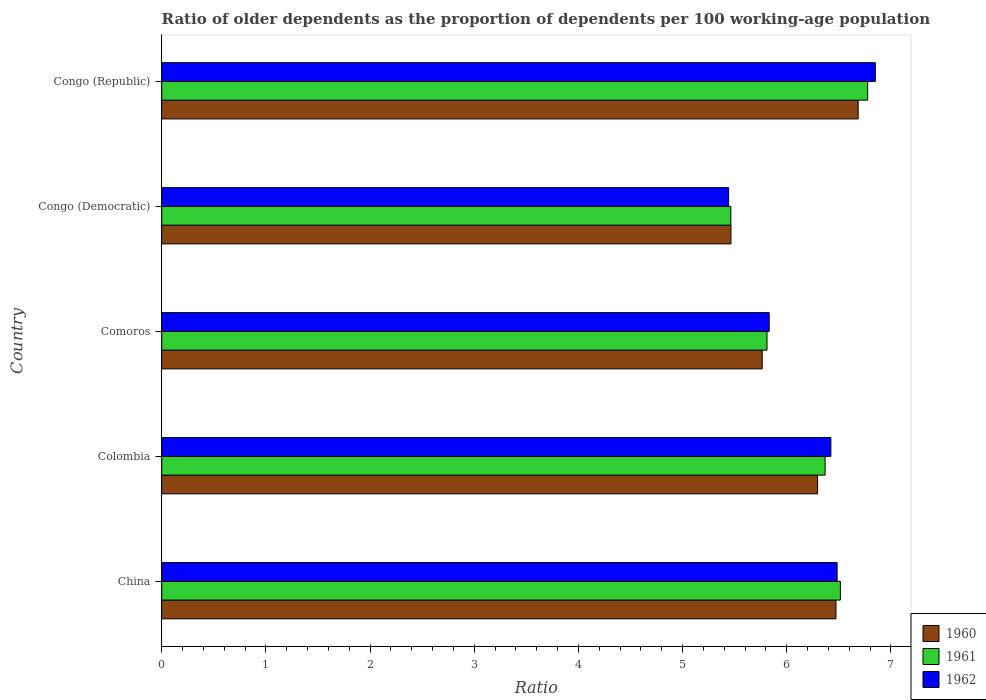Are the number of bars on each tick of the Y-axis equal?
Offer a terse response. Yes. How many bars are there on the 4th tick from the top?
Offer a terse response. 3. What is the label of the 3rd group of bars from the top?
Make the answer very short. Comoros. What is the age dependency ratio(old) in 1961 in Congo (Republic)?
Offer a terse response. 6.78. Across all countries, what is the maximum age dependency ratio(old) in 1962?
Your response must be concise. 6.85. Across all countries, what is the minimum age dependency ratio(old) in 1961?
Offer a very short reply. 5.46. In which country was the age dependency ratio(old) in 1962 maximum?
Give a very brief answer. Congo (Republic). In which country was the age dependency ratio(old) in 1962 minimum?
Ensure brevity in your answer.  Congo (Democratic). What is the total age dependency ratio(old) in 1962 in the graph?
Give a very brief answer. 31.03. What is the difference between the age dependency ratio(old) in 1961 in Colombia and that in Comoros?
Your answer should be compact. 0.56. What is the difference between the age dependency ratio(old) in 1962 in Comoros and the age dependency ratio(old) in 1960 in Congo (Democratic)?
Your response must be concise. 0.37. What is the average age dependency ratio(old) in 1962 per country?
Your answer should be compact. 6.21. What is the difference between the age dependency ratio(old) in 1961 and age dependency ratio(old) in 1962 in Comoros?
Make the answer very short. -0.02. What is the ratio of the age dependency ratio(old) in 1961 in Congo (Democratic) to that in Congo (Republic)?
Your answer should be very brief. 0.81. Is the age dependency ratio(old) in 1960 in China less than that in Colombia?
Give a very brief answer. No. What is the difference between the highest and the second highest age dependency ratio(old) in 1962?
Provide a short and direct response. 0.37. What is the difference between the highest and the lowest age dependency ratio(old) in 1962?
Your answer should be compact. 1.41. In how many countries, is the age dependency ratio(old) in 1960 greater than the average age dependency ratio(old) in 1960 taken over all countries?
Your answer should be compact. 3. Is the sum of the age dependency ratio(old) in 1962 in Colombia and Congo (Republic) greater than the maximum age dependency ratio(old) in 1960 across all countries?
Your answer should be very brief. Yes. Is it the case that in every country, the sum of the age dependency ratio(old) in 1961 and age dependency ratio(old) in 1960 is greater than the age dependency ratio(old) in 1962?
Give a very brief answer. Yes. How many bars are there?
Give a very brief answer. 15. Are all the bars in the graph horizontal?
Offer a terse response. Yes. How many countries are there in the graph?
Offer a terse response. 5. Does the graph contain any zero values?
Provide a short and direct response. No. Does the graph contain grids?
Your answer should be very brief. No. What is the title of the graph?
Provide a succinct answer. Ratio of older dependents as the proportion of dependents per 100 working-age population. What is the label or title of the X-axis?
Offer a very short reply. Ratio. What is the label or title of the Y-axis?
Your answer should be compact. Country. What is the Ratio of 1960 in China?
Provide a short and direct response. 6.47. What is the Ratio in 1961 in China?
Your answer should be compact. 6.51. What is the Ratio in 1962 in China?
Offer a terse response. 6.48. What is the Ratio in 1960 in Colombia?
Ensure brevity in your answer.  6.3. What is the Ratio in 1961 in Colombia?
Your answer should be very brief. 6.37. What is the Ratio of 1962 in Colombia?
Your answer should be compact. 6.42. What is the Ratio in 1960 in Comoros?
Your response must be concise. 5.76. What is the Ratio of 1961 in Comoros?
Ensure brevity in your answer.  5.81. What is the Ratio in 1962 in Comoros?
Keep it short and to the point. 5.83. What is the Ratio of 1960 in Congo (Democratic)?
Provide a short and direct response. 5.46. What is the Ratio of 1961 in Congo (Democratic)?
Make the answer very short. 5.46. What is the Ratio in 1962 in Congo (Democratic)?
Give a very brief answer. 5.44. What is the Ratio of 1960 in Congo (Republic)?
Give a very brief answer. 6.69. What is the Ratio in 1961 in Congo (Republic)?
Provide a short and direct response. 6.78. What is the Ratio in 1962 in Congo (Republic)?
Your answer should be compact. 6.85. Across all countries, what is the maximum Ratio in 1960?
Make the answer very short. 6.69. Across all countries, what is the maximum Ratio of 1961?
Provide a short and direct response. 6.78. Across all countries, what is the maximum Ratio of 1962?
Provide a succinct answer. 6.85. Across all countries, what is the minimum Ratio of 1960?
Provide a short and direct response. 5.46. Across all countries, what is the minimum Ratio in 1961?
Ensure brevity in your answer.  5.46. Across all countries, what is the minimum Ratio in 1962?
Ensure brevity in your answer.  5.44. What is the total Ratio in 1960 in the graph?
Give a very brief answer. 30.68. What is the total Ratio of 1961 in the graph?
Make the answer very short. 30.93. What is the total Ratio in 1962 in the graph?
Provide a short and direct response. 31.03. What is the difference between the Ratio of 1960 in China and that in Colombia?
Provide a short and direct response. 0.18. What is the difference between the Ratio in 1961 in China and that in Colombia?
Your response must be concise. 0.15. What is the difference between the Ratio of 1960 in China and that in Comoros?
Provide a succinct answer. 0.71. What is the difference between the Ratio of 1961 in China and that in Comoros?
Offer a terse response. 0.7. What is the difference between the Ratio in 1962 in China and that in Comoros?
Provide a succinct answer. 0.65. What is the difference between the Ratio of 1960 in China and that in Congo (Democratic)?
Your answer should be compact. 1.01. What is the difference between the Ratio of 1961 in China and that in Congo (Democratic)?
Offer a terse response. 1.05. What is the difference between the Ratio in 1962 in China and that in Congo (Democratic)?
Your answer should be very brief. 1.04. What is the difference between the Ratio in 1960 in China and that in Congo (Republic)?
Keep it short and to the point. -0.21. What is the difference between the Ratio in 1961 in China and that in Congo (Republic)?
Ensure brevity in your answer.  -0.26. What is the difference between the Ratio of 1962 in China and that in Congo (Republic)?
Ensure brevity in your answer.  -0.37. What is the difference between the Ratio in 1960 in Colombia and that in Comoros?
Your response must be concise. 0.53. What is the difference between the Ratio of 1961 in Colombia and that in Comoros?
Your answer should be very brief. 0.56. What is the difference between the Ratio in 1962 in Colombia and that in Comoros?
Your response must be concise. 0.59. What is the difference between the Ratio in 1960 in Colombia and that in Congo (Democratic)?
Offer a very short reply. 0.83. What is the difference between the Ratio of 1961 in Colombia and that in Congo (Democratic)?
Your answer should be very brief. 0.91. What is the difference between the Ratio in 1962 in Colombia and that in Congo (Democratic)?
Offer a terse response. 0.98. What is the difference between the Ratio of 1960 in Colombia and that in Congo (Republic)?
Offer a very short reply. -0.39. What is the difference between the Ratio of 1961 in Colombia and that in Congo (Republic)?
Offer a terse response. -0.41. What is the difference between the Ratio in 1962 in Colombia and that in Congo (Republic)?
Give a very brief answer. -0.43. What is the difference between the Ratio in 1960 in Comoros and that in Congo (Democratic)?
Your answer should be very brief. 0.3. What is the difference between the Ratio in 1961 in Comoros and that in Congo (Democratic)?
Provide a short and direct response. 0.35. What is the difference between the Ratio of 1962 in Comoros and that in Congo (Democratic)?
Give a very brief answer. 0.39. What is the difference between the Ratio in 1960 in Comoros and that in Congo (Republic)?
Your answer should be compact. -0.92. What is the difference between the Ratio of 1961 in Comoros and that in Congo (Republic)?
Offer a very short reply. -0.97. What is the difference between the Ratio of 1962 in Comoros and that in Congo (Republic)?
Your answer should be very brief. -1.02. What is the difference between the Ratio of 1960 in Congo (Democratic) and that in Congo (Republic)?
Give a very brief answer. -1.22. What is the difference between the Ratio of 1961 in Congo (Democratic) and that in Congo (Republic)?
Provide a succinct answer. -1.31. What is the difference between the Ratio of 1962 in Congo (Democratic) and that in Congo (Republic)?
Offer a terse response. -1.41. What is the difference between the Ratio of 1960 in China and the Ratio of 1961 in Colombia?
Provide a succinct answer. 0.1. What is the difference between the Ratio of 1960 in China and the Ratio of 1962 in Colombia?
Ensure brevity in your answer.  0.05. What is the difference between the Ratio in 1961 in China and the Ratio in 1962 in Colombia?
Make the answer very short. 0.09. What is the difference between the Ratio of 1960 in China and the Ratio of 1961 in Comoros?
Offer a very short reply. 0.66. What is the difference between the Ratio in 1960 in China and the Ratio in 1962 in Comoros?
Your response must be concise. 0.64. What is the difference between the Ratio of 1961 in China and the Ratio of 1962 in Comoros?
Your answer should be very brief. 0.68. What is the difference between the Ratio in 1960 in China and the Ratio in 1961 in Congo (Democratic)?
Give a very brief answer. 1.01. What is the difference between the Ratio of 1960 in China and the Ratio of 1962 in Congo (Democratic)?
Provide a short and direct response. 1.03. What is the difference between the Ratio in 1961 in China and the Ratio in 1962 in Congo (Democratic)?
Your answer should be very brief. 1.07. What is the difference between the Ratio of 1960 in China and the Ratio of 1961 in Congo (Republic)?
Offer a very short reply. -0.3. What is the difference between the Ratio in 1960 in China and the Ratio in 1962 in Congo (Republic)?
Your response must be concise. -0.38. What is the difference between the Ratio of 1961 in China and the Ratio of 1962 in Congo (Republic)?
Provide a succinct answer. -0.34. What is the difference between the Ratio of 1960 in Colombia and the Ratio of 1961 in Comoros?
Your answer should be compact. 0.49. What is the difference between the Ratio of 1960 in Colombia and the Ratio of 1962 in Comoros?
Offer a terse response. 0.46. What is the difference between the Ratio in 1961 in Colombia and the Ratio in 1962 in Comoros?
Provide a short and direct response. 0.54. What is the difference between the Ratio in 1960 in Colombia and the Ratio in 1961 in Congo (Democratic)?
Ensure brevity in your answer.  0.83. What is the difference between the Ratio in 1960 in Colombia and the Ratio in 1962 in Congo (Democratic)?
Your response must be concise. 0.85. What is the difference between the Ratio of 1961 in Colombia and the Ratio of 1962 in Congo (Democratic)?
Make the answer very short. 0.93. What is the difference between the Ratio in 1960 in Colombia and the Ratio in 1961 in Congo (Republic)?
Offer a very short reply. -0.48. What is the difference between the Ratio in 1960 in Colombia and the Ratio in 1962 in Congo (Republic)?
Offer a very short reply. -0.55. What is the difference between the Ratio of 1961 in Colombia and the Ratio of 1962 in Congo (Republic)?
Keep it short and to the point. -0.48. What is the difference between the Ratio of 1960 in Comoros and the Ratio of 1961 in Congo (Democratic)?
Give a very brief answer. 0.3. What is the difference between the Ratio in 1960 in Comoros and the Ratio in 1962 in Congo (Democratic)?
Keep it short and to the point. 0.32. What is the difference between the Ratio in 1961 in Comoros and the Ratio in 1962 in Congo (Democratic)?
Keep it short and to the point. 0.37. What is the difference between the Ratio in 1960 in Comoros and the Ratio in 1961 in Congo (Republic)?
Your response must be concise. -1.01. What is the difference between the Ratio in 1960 in Comoros and the Ratio in 1962 in Congo (Republic)?
Give a very brief answer. -1.09. What is the difference between the Ratio of 1961 in Comoros and the Ratio of 1962 in Congo (Republic)?
Provide a succinct answer. -1.04. What is the difference between the Ratio in 1960 in Congo (Democratic) and the Ratio in 1961 in Congo (Republic)?
Keep it short and to the point. -1.31. What is the difference between the Ratio in 1960 in Congo (Democratic) and the Ratio in 1962 in Congo (Republic)?
Provide a short and direct response. -1.39. What is the difference between the Ratio of 1961 in Congo (Democratic) and the Ratio of 1962 in Congo (Republic)?
Provide a succinct answer. -1.39. What is the average Ratio in 1960 per country?
Your answer should be compact. 6.14. What is the average Ratio of 1961 per country?
Provide a succinct answer. 6.19. What is the average Ratio in 1962 per country?
Ensure brevity in your answer.  6.21. What is the difference between the Ratio in 1960 and Ratio in 1961 in China?
Offer a terse response. -0.04. What is the difference between the Ratio of 1960 and Ratio of 1962 in China?
Offer a very short reply. -0.01. What is the difference between the Ratio of 1961 and Ratio of 1962 in China?
Offer a terse response. 0.03. What is the difference between the Ratio in 1960 and Ratio in 1961 in Colombia?
Your response must be concise. -0.07. What is the difference between the Ratio in 1960 and Ratio in 1962 in Colombia?
Offer a very short reply. -0.13. What is the difference between the Ratio of 1961 and Ratio of 1962 in Colombia?
Provide a short and direct response. -0.06. What is the difference between the Ratio of 1960 and Ratio of 1961 in Comoros?
Give a very brief answer. -0.05. What is the difference between the Ratio of 1960 and Ratio of 1962 in Comoros?
Your answer should be compact. -0.07. What is the difference between the Ratio in 1961 and Ratio in 1962 in Comoros?
Provide a succinct answer. -0.02. What is the difference between the Ratio in 1960 and Ratio in 1961 in Congo (Democratic)?
Ensure brevity in your answer.  0. What is the difference between the Ratio in 1960 and Ratio in 1962 in Congo (Democratic)?
Provide a succinct answer. 0.02. What is the difference between the Ratio in 1961 and Ratio in 1962 in Congo (Democratic)?
Make the answer very short. 0.02. What is the difference between the Ratio of 1960 and Ratio of 1961 in Congo (Republic)?
Ensure brevity in your answer.  -0.09. What is the difference between the Ratio of 1960 and Ratio of 1962 in Congo (Republic)?
Give a very brief answer. -0.16. What is the difference between the Ratio of 1961 and Ratio of 1962 in Congo (Republic)?
Provide a succinct answer. -0.07. What is the ratio of the Ratio in 1960 in China to that in Colombia?
Your answer should be very brief. 1.03. What is the ratio of the Ratio in 1962 in China to that in Colombia?
Your response must be concise. 1.01. What is the ratio of the Ratio in 1960 in China to that in Comoros?
Your answer should be very brief. 1.12. What is the ratio of the Ratio of 1961 in China to that in Comoros?
Give a very brief answer. 1.12. What is the ratio of the Ratio of 1962 in China to that in Comoros?
Your answer should be compact. 1.11. What is the ratio of the Ratio of 1960 in China to that in Congo (Democratic)?
Your answer should be compact. 1.18. What is the ratio of the Ratio in 1961 in China to that in Congo (Democratic)?
Keep it short and to the point. 1.19. What is the ratio of the Ratio of 1962 in China to that in Congo (Democratic)?
Provide a short and direct response. 1.19. What is the ratio of the Ratio of 1960 in China to that in Congo (Republic)?
Your answer should be compact. 0.97. What is the ratio of the Ratio of 1961 in China to that in Congo (Republic)?
Your response must be concise. 0.96. What is the ratio of the Ratio of 1962 in China to that in Congo (Republic)?
Make the answer very short. 0.95. What is the ratio of the Ratio of 1960 in Colombia to that in Comoros?
Provide a succinct answer. 1.09. What is the ratio of the Ratio of 1961 in Colombia to that in Comoros?
Offer a very short reply. 1.1. What is the ratio of the Ratio of 1962 in Colombia to that in Comoros?
Make the answer very short. 1.1. What is the ratio of the Ratio of 1960 in Colombia to that in Congo (Democratic)?
Give a very brief answer. 1.15. What is the ratio of the Ratio in 1961 in Colombia to that in Congo (Democratic)?
Provide a short and direct response. 1.17. What is the ratio of the Ratio in 1962 in Colombia to that in Congo (Democratic)?
Make the answer very short. 1.18. What is the ratio of the Ratio in 1960 in Colombia to that in Congo (Republic)?
Provide a succinct answer. 0.94. What is the ratio of the Ratio of 1961 in Colombia to that in Congo (Republic)?
Make the answer very short. 0.94. What is the ratio of the Ratio in 1962 in Colombia to that in Congo (Republic)?
Your response must be concise. 0.94. What is the ratio of the Ratio of 1960 in Comoros to that in Congo (Democratic)?
Your answer should be very brief. 1.05. What is the ratio of the Ratio in 1961 in Comoros to that in Congo (Democratic)?
Keep it short and to the point. 1.06. What is the ratio of the Ratio of 1962 in Comoros to that in Congo (Democratic)?
Offer a very short reply. 1.07. What is the ratio of the Ratio of 1960 in Comoros to that in Congo (Republic)?
Keep it short and to the point. 0.86. What is the ratio of the Ratio of 1961 in Comoros to that in Congo (Republic)?
Keep it short and to the point. 0.86. What is the ratio of the Ratio of 1962 in Comoros to that in Congo (Republic)?
Your response must be concise. 0.85. What is the ratio of the Ratio in 1960 in Congo (Democratic) to that in Congo (Republic)?
Give a very brief answer. 0.82. What is the ratio of the Ratio of 1961 in Congo (Democratic) to that in Congo (Republic)?
Offer a terse response. 0.81. What is the ratio of the Ratio in 1962 in Congo (Democratic) to that in Congo (Republic)?
Make the answer very short. 0.79. What is the difference between the highest and the second highest Ratio of 1960?
Offer a terse response. 0.21. What is the difference between the highest and the second highest Ratio in 1961?
Keep it short and to the point. 0.26. What is the difference between the highest and the second highest Ratio of 1962?
Give a very brief answer. 0.37. What is the difference between the highest and the lowest Ratio of 1960?
Make the answer very short. 1.22. What is the difference between the highest and the lowest Ratio of 1961?
Offer a terse response. 1.31. What is the difference between the highest and the lowest Ratio in 1962?
Give a very brief answer. 1.41. 